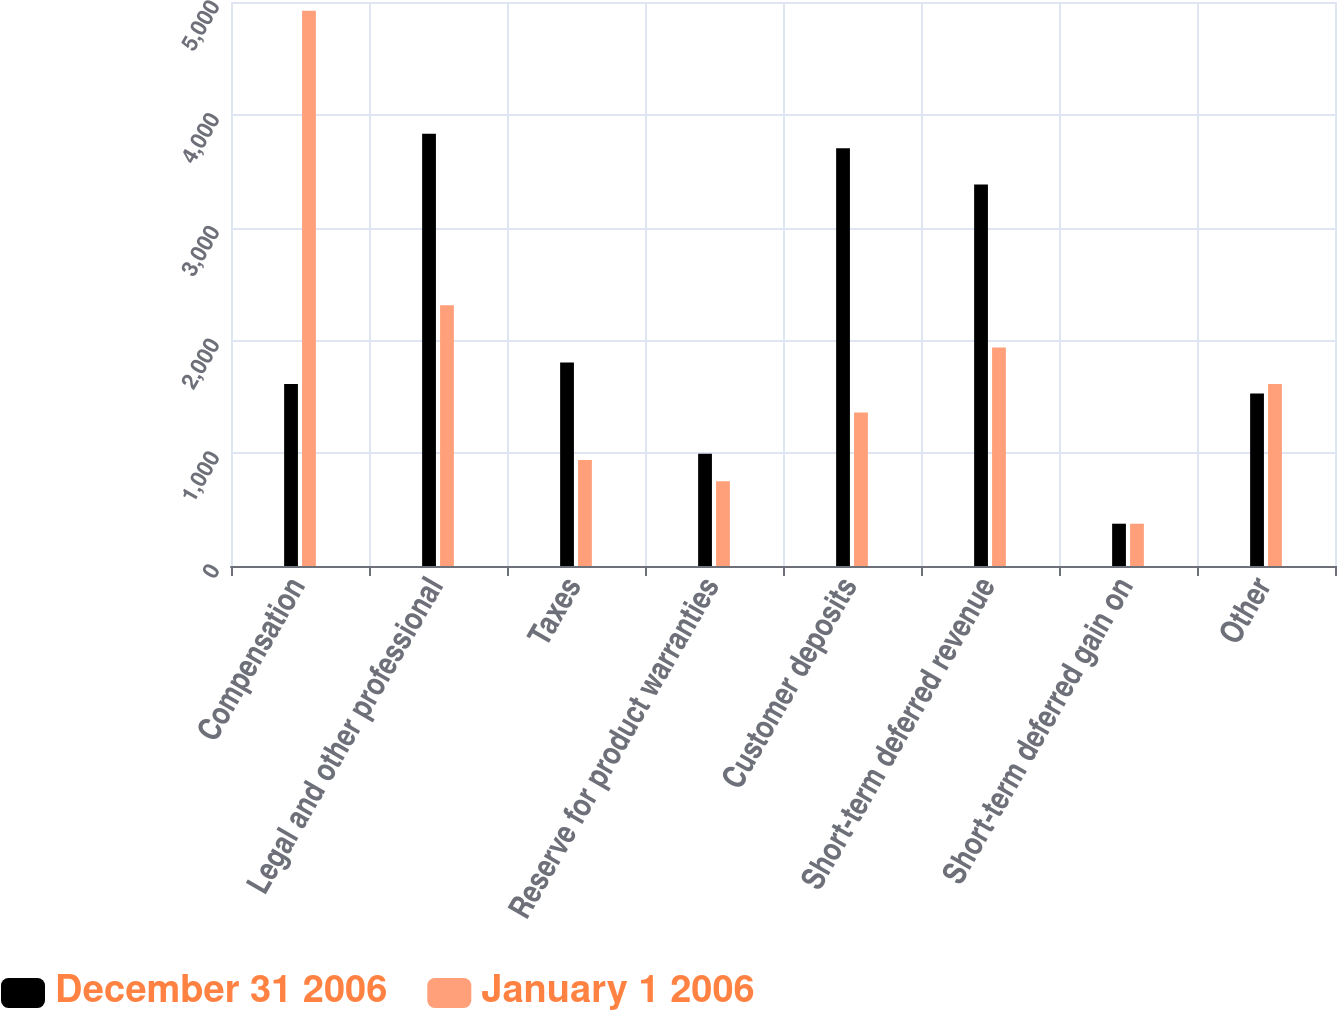<chart> <loc_0><loc_0><loc_500><loc_500><stacked_bar_chart><ecel><fcel>Compensation<fcel>Legal and other professional<fcel>Taxes<fcel>Reserve for product warranties<fcel>Customer deposits<fcel>Short-term deferred revenue<fcel>Short-term deferred gain on<fcel>Other<nl><fcel>December 31 2006<fcel>1614<fcel>3831<fcel>1804<fcel>996<fcel>3703<fcel>3382<fcel>375<fcel>1530<nl><fcel>January 1 2006<fcel>4922<fcel>2311<fcel>939<fcel>751<fcel>1361<fcel>1937<fcel>375<fcel>1614<nl></chart> 